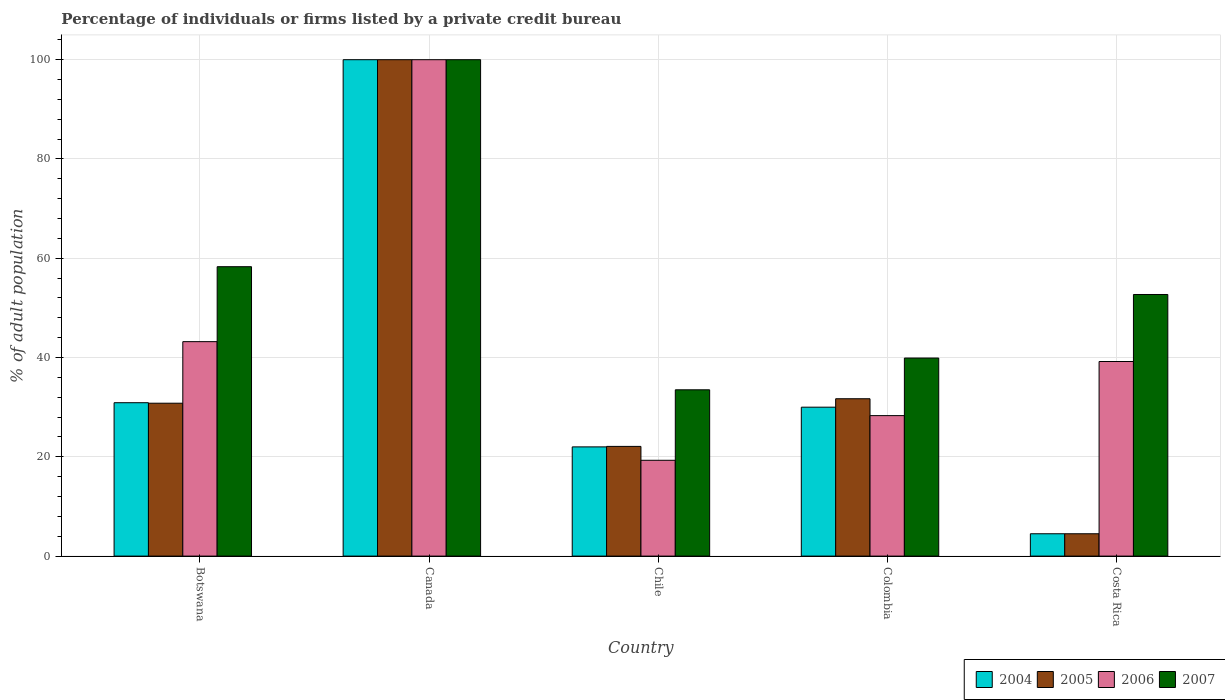Are the number of bars per tick equal to the number of legend labels?
Your answer should be very brief. Yes. Are the number of bars on each tick of the X-axis equal?
Your answer should be compact. Yes. How many bars are there on the 3rd tick from the right?
Give a very brief answer. 4. What is the label of the 2nd group of bars from the left?
Your answer should be compact. Canada. In how many cases, is the number of bars for a given country not equal to the number of legend labels?
Provide a short and direct response. 0. What is the percentage of population listed by a private credit bureau in 2006 in Costa Rica?
Make the answer very short. 39.2. Across all countries, what is the maximum percentage of population listed by a private credit bureau in 2005?
Your answer should be compact. 100. Across all countries, what is the minimum percentage of population listed by a private credit bureau in 2005?
Make the answer very short. 4.5. What is the total percentage of population listed by a private credit bureau in 2007 in the graph?
Offer a very short reply. 284.4. What is the difference between the percentage of population listed by a private credit bureau in 2007 in Canada and that in Chile?
Ensure brevity in your answer.  66.5. What is the difference between the percentage of population listed by a private credit bureau in 2007 in Botswana and the percentage of population listed by a private credit bureau in 2006 in Canada?
Provide a short and direct response. -41.7. What is the average percentage of population listed by a private credit bureau in 2005 per country?
Your answer should be very brief. 37.82. What is the difference between the percentage of population listed by a private credit bureau of/in 2005 and percentage of population listed by a private credit bureau of/in 2004 in Canada?
Your answer should be very brief. 0. What is the ratio of the percentage of population listed by a private credit bureau in 2004 in Botswana to that in Costa Rica?
Make the answer very short. 6.87. Is the percentage of population listed by a private credit bureau in 2005 in Botswana less than that in Canada?
Offer a very short reply. Yes. What is the difference between the highest and the second highest percentage of population listed by a private credit bureau in 2004?
Provide a succinct answer. 69.1. What is the difference between the highest and the lowest percentage of population listed by a private credit bureau in 2006?
Provide a succinct answer. 80.7. In how many countries, is the percentage of population listed by a private credit bureau in 2005 greater than the average percentage of population listed by a private credit bureau in 2005 taken over all countries?
Offer a terse response. 1. How many bars are there?
Offer a very short reply. 20. Are all the bars in the graph horizontal?
Your answer should be very brief. No. How many countries are there in the graph?
Your response must be concise. 5. What is the difference between two consecutive major ticks on the Y-axis?
Give a very brief answer. 20. Does the graph contain any zero values?
Give a very brief answer. No. How many legend labels are there?
Keep it short and to the point. 4. What is the title of the graph?
Your answer should be compact. Percentage of individuals or firms listed by a private credit bureau. What is the label or title of the Y-axis?
Keep it short and to the point. % of adult population. What is the % of adult population in 2004 in Botswana?
Keep it short and to the point. 30.9. What is the % of adult population of 2005 in Botswana?
Provide a short and direct response. 30.8. What is the % of adult population of 2006 in Botswana?
Offer a terse response. 43.2. What is the % of adult population in 2007 in Botswana?
Your answer should be compact. 58.3. What is the % of adult population of 2005 in Canada?
Your answer should be compact. 100. What is the % of adult population of 2007 in Canada?
Your answer should be very brief. 100. What is the % of adult population of 2005 in Chile?
Make the answer very short. 22.1. What is the % of adult population of 2006 in Chile?
Your response must be concise. 19.3. What is the % of adult population of 2007 in Chile?
Ensure brevity in your answer.  33.5. What is the % of adult population of 2004 in Colombia?
Your answer should be very brief. 30. What is the % of adult population of 2005 in Colombia?
Ensure brevity in your answer.  31.7. What is the % of adult population of 2006 in Colombia?
Provide a succinct answer. 28.3. What is the % of adult population in 2007 in Colombia?
Ensure brevity in your answer.  39.9. What is the % of adult population of 2004 in Costa Rica?
Offer a very short reply. 4.5. What is the % of adult population of 2005 in Costa Rica?
Offer a very short reply. 4.5. What is the % of adult population in 2006 in Costa Rica?
Provide a short and direct response. 39.2. What is the % of adult population in 2007 in Costa Rica?
Ensure brevity in your answer.  52.7. Across all countries, what is the maximum % of adult population of 2004?
Your answer should be compact. 100. Across all countries, what is the minimum % of adult population in 2006?
Offer a very short reply. 19.3. Across all countries, what is the minimum % of adult population in 2007?
Give a very brief answer. 33.5. What is the total % of adult population in 2004 in the graph?
Provide a succinct answer. 187.4. What is the total % of adult population of 2005 in the graph?
Offer a very short reply. 189.1. What is the total % of adult population of 2006 in the graph?
Ensure brevity in your answer.  230. What is the total % of adult population of 2007 in the graph?
Offer a terse response. 284.4. What is the difference between the % of adult population in 2004 in Botswana and that in Canada?
Give a very brief answer. -69.1. What is the difference between the % of adult population of 2005 in Botswana and that in Canada?
Your response must be concise. -69.2. What is the difference between the % of adult population in 2006 in Botswana and that in Canada?
Your response must be concise. -56.8. What is the difference between the % of adult population in 2007 in Botswana and that in Canada?
Your answer should be very brief. -41.7. What is the difference between the % of adult population in 2005 in Botswana and that in Chile?
Offer a terse response. 8.7. What is the difference between the % of adult population in 2006 in Botswana and that in Chile?
Your answer should be compact. 23.9. What is the difference between the % of adult population in 2007 in Botswana and that in Chile?
Your response must be concise. 24.8. What is the difference between the % of adult population in 2004 in Botswana and that in Colombia?
Give a very brief answer. 0.9. What is the difference between the % of adult population of 2006 in Botswana and that in Colombia?
Your answer should be compact. 14.9. What is the difference between the % of adult population of 2004 in Botswana and that in Costa Rica?
Keep it short and to the point. 26.4. What is the difference between the % of adult population of 2005 in Botswana and that in Costa Rica?
Give a very brief answer. 26.3. What is the difference between the % of adult population in 2005 in Canada and that in Chile?
Offer a terse response. 77.9. What is the difference between the % of adult population of 2006 in Canada and that in Chile?
Keep it short and to the point. 80.7. What is the difference between the % of adult population in 2007 in Canada and that in Chile?
Offer a very short reply. 66.5. What is the difference between the % of adult population in 2004 in Canada and that in Colombia?
Offer a very short reply. 70. What is the difference between the % of adult population in 2005 in Canada and that in Colombia?
Give a very brief answer. 68.3. What is the difference between the % of adult population in 2006 in Canada and that in Colombia?
Provide a succinct answer. 71.7. What is the difference between the % of adult population in 2007 in Canada and that in Colombia?
Your answer should be compact. 60.1. What is the difference between the % of adult population in 2004 in Canada and that in Costa Rica?
Your answer should be very brief. 95.5. What is the difference between the % of adult population of 2005 in Canada and that in Costa Rica?
Your answer should be compact. 95.5. What is the difference between the % of adult population in 2006 in Canada and that in Costa Rica?
Your answer should be very brief. 60.8. What is the difference between the % of adult population of 2007 in Canada and that in Costa Rica?
Your answer should be very brief. 47.3. What is the difference between the % of adult population of 2004 in Chile and that in Colombia?
Your answer should be very brief. -8. What is the difference between the % of adult population in 2005 in Chile and that in Colombia?
Your answer should be compact. -9.6. What is the difference between the % of adult population in 2006 in Chile and that in Costa Rica?
Ensure brevity in your answer.  -19.9. What is the difference between the % of adult population of 2007 in Chile and that in Costa Rica?
Your response must be concise. -19.2. What is the difference between the % of adult population in 2005 in Colombia and that in Costa Rica?
Provide a short and direct response. 27.2. What is the difference between the % of adult population in 2007 in Colombia and that in Costa Rica?
Your answer should be very brief. -12.8. What is the difference between the % of adult population of 2004 in Botswana and the % of adult population of 2005 in Canada?
Your answer should be very brief. -69.1. What is the difference between the % of adult population in 2004 in Botswana and the % of adult population in 2006 in Canada?
Give a very brief answer. -69.1. What is the difference between the % of adult population in 2004 in Botswana and the % of adult population in 2007 in Canada?
Give a very brief answer. -69.1. What is the difference between the % of adult population in 2005 in Botswana and the % of adult population in 2006 in Canada?
Provide a succinct answer. -69.2. What is the difference between the % of adult population of 2005 in Botswana and the % of adult population of 2007 in Canada?
Ensure brevity in your answer.  -69.2. What is the difference between the % of adult population of 2006 in Botswana and the % of adult population of 2007 in Canada?
Your answer should be very brief. -56.8. What is the difference between the % of adult population of 2004 in Botswana and the % of adult population of 2005 in Chile?
Make the answer very short. 8.8. What is the difference between the % of adult population of 2004 in Botswana and the % of adult population of 2007 in Chile?
Offer a very short reply. -2.6. What is the difference between the % of adult population in 2004 in Botswana and the % of adult population in 2006 in Colombia?
Provide a short and direct response. 2.6. What is the difference between the % of adult population of 2006 in Botswana and the % of adult population of 2007 in Colombia?
Make the answer very short. 3.3. What is the difference between the % of adult population in 2004 in Botswana and the % of adult population in 2005 in Costa Rica?
Keep it short and to the point. 26.4. What is the difference between the % of adult population in 2004 in Botswana and the % of adult population in 2006 in Costa Rica?
Your answer should be compact. -8.3. What is the difference between the % of adult population of 2004 in Botswana and the % of adult population of 2007 in Costa Rica?
Offer a terse response. -21.8. What is the difference between the % of adult population in 2005 in Botswana and the % of adult population in 2006 in Costa Rica?
Your answer should be compact. -8.4. What is the difference between the % of adult population of 2005 in Botswana and the % of adult population of 2007 in Costa Rica?
Make the answer very short. -21.9. What is the difference between the % of adult population of 2004 in Canada and the % of adult population of 2005 in Chile?
Ensure brevity in your answer.  77.9. What is the difference between the % of adult population of 2004 in Canada and the % of adult population of 2006 in Chile?
Offer a very short reply. 80.7. What is the difference between the % of adult population of 2004 in Canada and the % of adult population of 2007 in Chile?
Offer a very short reply. 66.5. What is the difference between the % of adult population of 2005 in Canada and the % of adult population of 2006 in Chile?
Provide a succinct answer. 80.7. What is the difference between the % of adult population in 2005 in Canada and the % of adult population in 2007 in Chile?
Your response must be concise. 66.5. What is the difference between the % of adult population of 2006 in Canada and the % of adult population of 2007 in Chile?
Offer a very short reply. 66.5. What is the difference between the % of adult population of 2004 in Canada and the % of adult population of 2005 in Colombia?
Give a very brief answer. 68.3. What is the difference between the % of adult population of 2004 in Canada and the % of adult population of 2006 in Colombia?
Your answer should be compact. 71.7. What is the difference between the % of adult population of 2004 in Canada and the % of adult population of 2007 in Colombia?
Your response must be concise. 60.1. What is the difference between the % of adult population in 2005 in Canada and the % of adult population in 2006 in Colombia?
Offer a terse response. 71.7. What is the difference between the % of adult population in 2005 in Canada and the % of adult population in 2007 in Colombia?
Give a very brief answer. 60.1. What is the difference between the % of adult population in 2006 in Canada and the % of adult population in 2007 in Colombia?
Make the answer very short. 60.1. What is the difference between the % of adult population of 2004 in Canada and the % of adult population of 2005 in Costa Rica?
Provide a succinct answer. 95.5. What is the difference between the % of adult population of 2004 in Canada and the % of adult population of 2006 in Costa Rica?
Provide a succinct answer. 60.8. What is the difference between the % of adult population in 2004 in Canada and the % of adult population in 2007 in Costa Rica?
Keep it short and to the point. 47.3. What is the difference between the % of adult population in 2005 in Canada and the % of adult population in 2006 in Costa Rica?
Make the answer very short. 60.8. What is the difference between the % of adult population of 2005 in Canada and the % of adult population of 2007 in Costa Rica?
Your answer should be very brief. 47.3. What is the difference between the % of adult population of 2006 in Canada and the % of adult population of 2007 in Costa Rica?
Your answer should be very brief. 47.3. What is the difference between the % of adult population of 2004 in Chile and the % of adult population of 2005 in Colombia?
Ensure brevity in your answer.  -9.7. What is the difference between the % of adult population in 2004 in Chile and the % of adult population in 2006 in Colombia?
Give a very brief answer. -6.3. What is the difference between the % of adult population of 2004 in Chile and the % of adult population of 2007 in Colombia?
Your answer should be very brief. -17.9. What is the difference between the % of adult population in 2005 in Chile and the % of adult population in 2006 in Colombia?
Your response must be concise. -6.2. What is the difference between the % of adult population in 2005 in Chile and the % of adult population in 2007 in Colombia?
Provide a succinct answer. -17.8. What is the difference between the % of adult population in 2006 in Chile and the % of adult population in 2007 in Colombia?
Give a very brief answer. -20.6. What is the difference between the % of adult population of 2004 in Chile and the % of adult population of 2006 in Costa Rica?
Provide a short and direct response. -17.2. What is the difference between the % of adult population in 2004 in Chile and the % of adult population in 2007 in Costa Rica?
Your answer should be very brief. -30.7. What is the difference between the % of adult population of 2005 in Chile and the % of adult population of 2006 in Costa Rica?
Offer a very short reply. -17.1. What is the difference between the % of adult population in 2005 in Chile and the % of adult population in 2007 in Costa Rica?
Offer a terse response. -30.6. What is the difference between the % of adult population in 2006 in Chile and the % of adult population in 2007 in Costa Rica?
Ensure brevity in your answer.  -33.4. What is the difference between the % of adult population of 2004 in Colombia and the % of adult population of 2005 in Costa Rica?
Provide a succinct answer. 25.5. What is the difference between the % of adult population in 2004 in Colombia and the % of adult population in 2007 in Costa Rica?
Make the answer very short. -22.7. What is the difference between the % of adult population of 2005 in Colombia and the % of adult population of 2007 in Costa Rica?
Your response must be concise. -21. What is the difference between the % of adult population in 2006 in Colombia and the % of adult population in 2007 in Costa Rica?
Your answer should be very brief. -24.4. What is the average % of adult population in 2004 per country?
Keep it short and to the point. 37.48. What is the average % of adult population of 2005 per country?
Make the answer very short. 37.82. What is the average % of adult population in 2006 per country?
Offer a very short reply. 46. What is the average % of adult population of 2007 per country?
Ensure brevity in your answer.  56.88. What is the difference between the % of adult population of 2004 and % of adult population of 2007 in Botswana?
Provide a short and direct response. -27.4. What is the difference between the % of adult population in 2005 and % of adult population in 2006 in Botswana?
Your response must be concise. -12.4. What is the difference between the % of adult population of 2005 and % of adult population of 2007 in Botswana?
Provide a short and direct response. -27.5. What is the difference between the % of adult population in 2006 and % of adult population in 2007 in Botswana?
Provide a succinct answer. -15.1. What is the difference between the % of adult population in 2004 and % of adult population in 2007 in Canada?
Offer a very short reply. 0. What is the difference between the % of adult population in 2005 and % of adult population in 2006 in Canada?
Give a very brief answer. 0. What is the difference between the % of adult population of 2005 and % of adult population of 2007 in Chile?
Make the answer very short. -11.4. What is the difference between the % of adult population of 2006 and % of adult population of 2007 in Chile?
Ensure brevity in your answer.  -14.2. What is the difference between the % of adult population in 2004 and % of adult population in 2006 in Colombia?
Ensure brevity in your answer.  1.7. What is the difference between the % of adult population in 2004 and % of adult population in 2007 in Colombia?
Provide a succinct answer. -9.9. What is the difference between the % of adult population of 2004 and % of adult population of 2005 in Costa Rica?
Ensure brevity in your answer.  0. What is the difference between the % of adult population of 2004 and % of adult population of 2006 in Costa Rica?
Keep it short and to the point. -34.7. What is the difference between the % of adult population in 2004 and % of adult population in 2007 in Costa Rica?
Provide a short and direct response. -48.2. What is the difference between the % of adult population in 2005 and % of adult population in 2006 in Costa Rica?
Make the answer very short. -34.7. What is the difference between the % of adult population in 2005 and % of adult population in 2007 in Costa Rica?
Your answer should be compact. -48.2. What is the ratio of the % of adult population of 2004 in Botswana to that in Canada?
Give a very brief answer. 0.31. What is the ratio of the % of adult population in 2005 in Botswana to that in Canada?
Your answer should be compact. 0.31. What is the ratio of the % of adult population of 2006 in Botswana to that in Canada?
Your answer should be very brief. 0.43. What is the ratio of the % of adult population of 2007 in Botswana to that in Canada?
Make the answer very short. 0.58. What is the ratio of the % of adult population of 2004 in Botswana to that in Chile?
Your answer should be compact. 1.4. What is the ratio of the % of adult population in 2005 in Botswana to that in Chile?
Your response must be concise. 1.39. What is the ratio of the % of adult population of 2006 in Botswana to that in Chile?
Your answer should be compact. 2.24. What is the ratio of the % of adult population in 2007 in Botswana to that in Chile?
Your response must be concise. 1.74. What is the ratio of the % of adult population of 2005 in Botswana to that in Colombia?
Provide a short and direct response. 0.97. What is the ratio of the % of adult population in 2006 in Botswana to that in Colombia?
Keep it short and to the point. 1.53. What is the ratio of the % of adult population in 2007 in Botswana to that in Colombia?
Your answer should be very brief. 1.46. What is the ratio of the % of adult population in 2004 in Botswana to that in Costa Rica?
Ensure brevity in your answer.  6.87. What is the ratio of the % of adult population of 2005 in Botswana to that in Costa Rica?
Your response must be concise. 6.84. What is the ratio of the % of adult population of 2006 in Botswana to that in Costa Rica?
Offer a very short reply. 1.1. What is the ratio of the % of adult population of 2007 in Botswana to that in Costa Rica?
Provide a short and direct response. 1.11. What is the ratio of the % of adult population in 2004 in Canada to that in Chile?
Make the answer very short. 4.55. What is the ratio of the % of adult population of 2005 in Canada to that in Chile?
Provide a short and direct response. 4.52. What is the ratio of the % of adult population of 2006 in Canada to that in Chile?
Provide a succinct answer. 5.18. What is the ratio of the % of adult population of 2007 in Canada to that in Chile?
Keep it short and to the point. 2.99. What is the ratio of the % of adult population in 2004 in Canada to that in Colombia?
Give a very brief answer. 3.33. What is the ratio of the % of adult population of 2005 in Canada to that in Colombia?
Ensure brevity in your answer.  3.15. What is the ratio of the % of adult population of 2006 in Canada to that in Colombia?
Provide a short and direct response. 3.53. What is the ratio of the % of adult population of 2007 in Canada to that in Colombia?
Your answer should be very brief. 2.51. What is the ratio of the % of adult population of 2004 in Canada to that in Costa Rica?
Your answer should be very brief. 22.22. What is the ratio of the % of adult population of 2005 in Canada to that in Costa Rica?
Keep it short and to the point. 22.22. What is the ratio of the % of adult population of 2006 in Canada to that in Costa Rica?
Offer a terse response. 2.55. What is the ratio of the % of adult population of 2007 in Canada to that in Costa Rica?
Provide a short and direct response. 1.9. What is the ratio of the % of adult population in 2004 in Chile to that in Colombia?
Keep it short and to the point. 0.73. What is the ratio of the % of adult population in 2005 in Chile to that in Colombia?
Your answer should be very brief. 0.7. What is the ratio of the % of adult population of 2006 in Chile to that in Colombia?
Give a very brief answer. 0.68. What is the ratio of the % of adult population of 2007 in Chile to that in Colombia?
Offer a very short reply. 0.84. What is the ratio of the % of adult population of 2004 in Chile to that in Costa Rica?
Offer a very short reply. 4.89. What is the ratio of the % of adult population in 2005 in Chile to that in Costa Rica?
Your answer should be compact. 4.91. What is the ratio of the % of adult population in 2006 in Chile to that in Costa Rica?
Your answer should be very brief. 0.49. What is the ratio of the % of adult population in 2007 in Chile to that in Costa Rica?
Ensure brevity in your answer.  0.64. What is the ratio of the % of adult population of 2005 in Colombia to that in Costa Rica?
Ensure brevity in your answer.  7.04. What is the ratio of the % of adult population of 2006 in Colombia to that in Costa Rica?
Provide a short and direct response. 0.72. What is the ratio of the % of adult population of 2007 in Colombia to that in Costa Rica?
Provide a succinct answer. 0.76. What is the difference between the highest and the second highest % of adult population in 2004?
Give a very brief answer. 69.1. What is the difference between the highest and the second highest % of adult population in 2005?
Your answer should be compact. 68.3. What is the difference between the highest and the second highest % of adult population in 2006?
Provide a short and direct response. 56.8. What is the difference between the highest and the second highest % of adult population of 2007?
Make the answer very short. 41.7. What is the difference between the highest and the lowest % of adult population in 2004?
Give a very brief answer. 95.5. What is the difference between the highest and the lowest % of adult population in 2005?
Give a very brief answer. 95.5. What is the difference between the highest and the lowest % of adult population of 2006?
Keep it short and to the point. 80.7. What is the difference between the highest and the lowest % of adult population in 2007?
Provide a succinct answer. 66.5. 